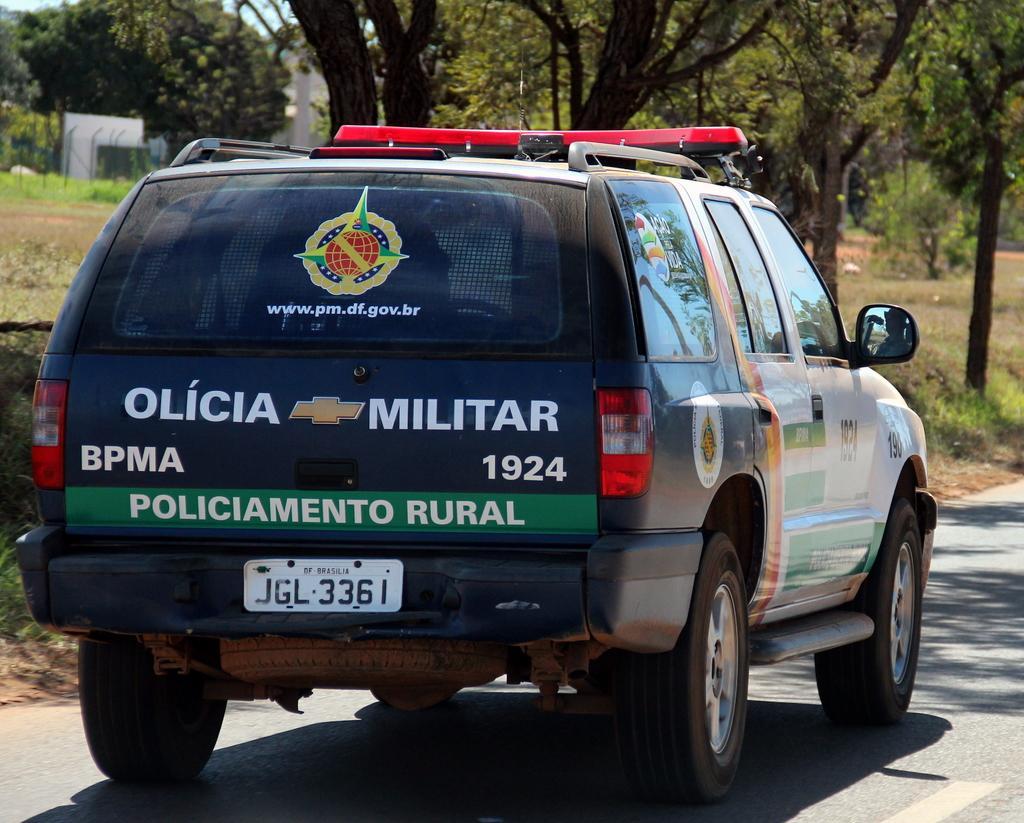Could you give a brief overview of what you see in this image? In this image we can see a car on the road. We can also see some grass, the bark of the trees, a metal fence, a group of trees, a building and the sky. 